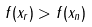Convert formula to latex. <formula><loc_0><loc_0><loc_500><loc_500>f ( x _ { r } ) > f ( x _ { n } )</formula> 